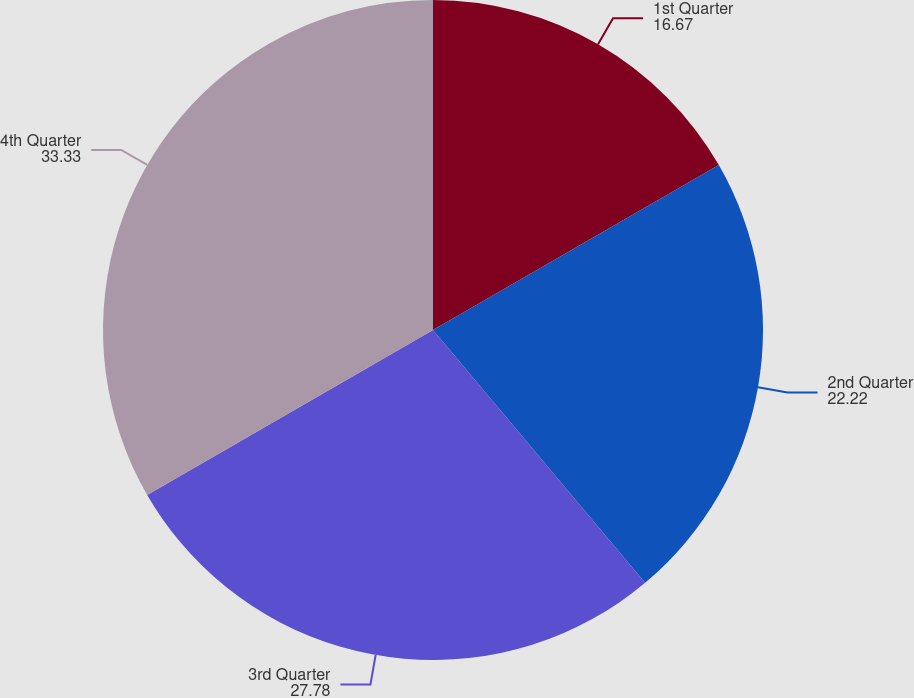Convert chart to OTSL. <chart><loc_0><loc_0><loc_500><loc_500><pie_chart><fcel>1st Quarter<fcel>2nd Quarter<fcel>3rd Quarter<fcel>4th Quarter<nl><fcel>16.67%<fcel>22.22%<fcel>27.78%<fcel>33.33%<nl></chart> 